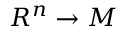Convert formula to latex. <formula><loc_0><loc_0><loc_500><loc_500>R ^ { n } \to M</formula> 